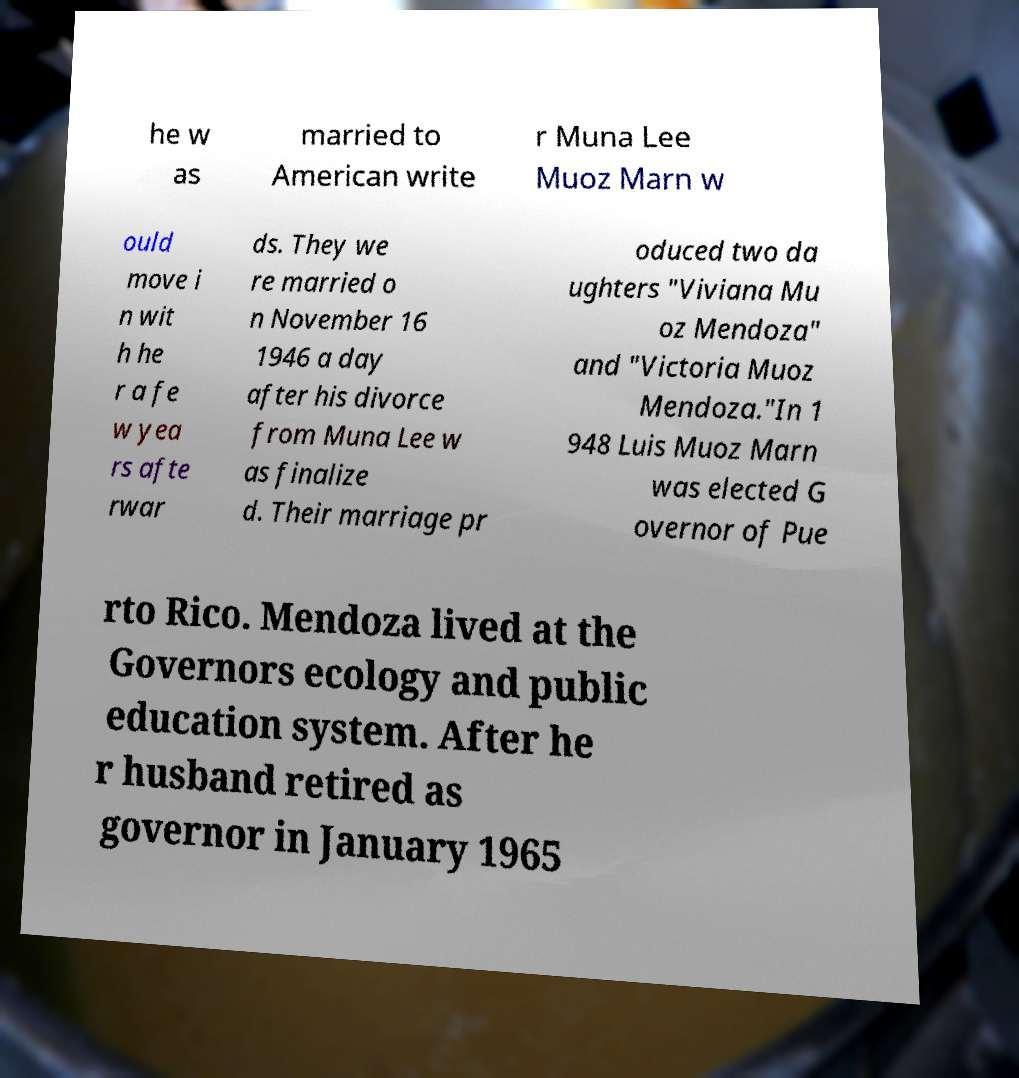Could you extract and type out the text from this image? he w as married to American write r Muna Lee Muoz Marn w ould move i n wit h he r a fe w yea rs afte rwar ds. They we re married o n November 16 1946 a day after his divorce from Muna Lee w as finalize d. Their marriage pr oduced two da ughters "Viviana Mu oz Mendoza" and "Victoria Muoz Mendoza."In 1 948 Luis Muoz Marn was elected G overnor of Pue rto Rico. Mendoza lived at the Governors ecology and public education system. After he r husband retired as governor in January 1965 